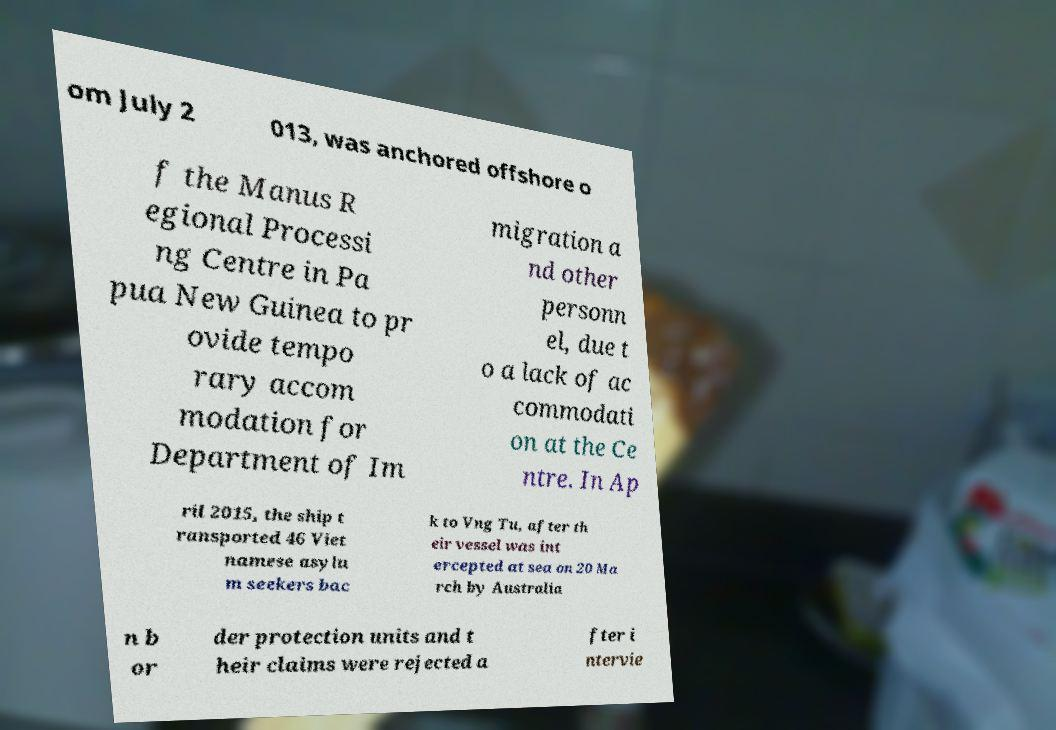Could you assist in decoding the text presented in this image and type it out clearly? om July 2 013, was anchored offshore o f the Manus R egional Processi ng Centre in Pa pua New Guinea to pr ovide tempo rary accom modation for Department of Im migration a nd other personn el, due t o a lack of ac commodati on at the Ce ntre. In Ap ril 2015, the ship t ransported 46 Viet namese asylu m seekers bac k to Vng Tu, after th eir vessel was int ercepted at sea on 20 Ma rch by Australia n b or der protection units and t heir claims were rejected a fter i ntervie 